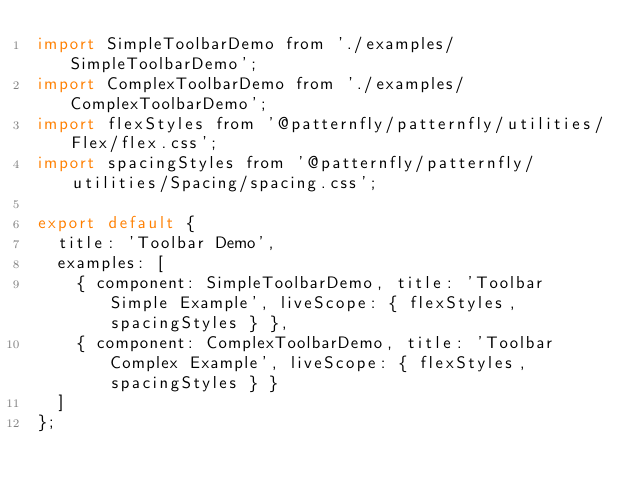<code> <loc_0><loc_0><loc_500><loc_500><_JavaScript_>import SimpleToolbarDemo from './examples/SimpleToolbarDemo';
import ComplexToolbarDemo from './examples/ComplexToolbarDemo';
import flexStyles from '@patternfly/patternfly/utilities/Flex/flex.css';
import spacingStyles from '@patternfly/patternfly/utilities/Spacing/spacing.css';

export default {
  title: 'Toolbar Demo',
  examples: [
    { component: SimpleToolbarDemo, title: 'Toolbar Simple Example', liveScope: { flexStyles, spacingStyles } },
    { component: ComplexToolbarDemo, title: 'Toolbar Complex Example', liveScope: { flexStyles, spacingStyles } }
  ]
};
</code> 